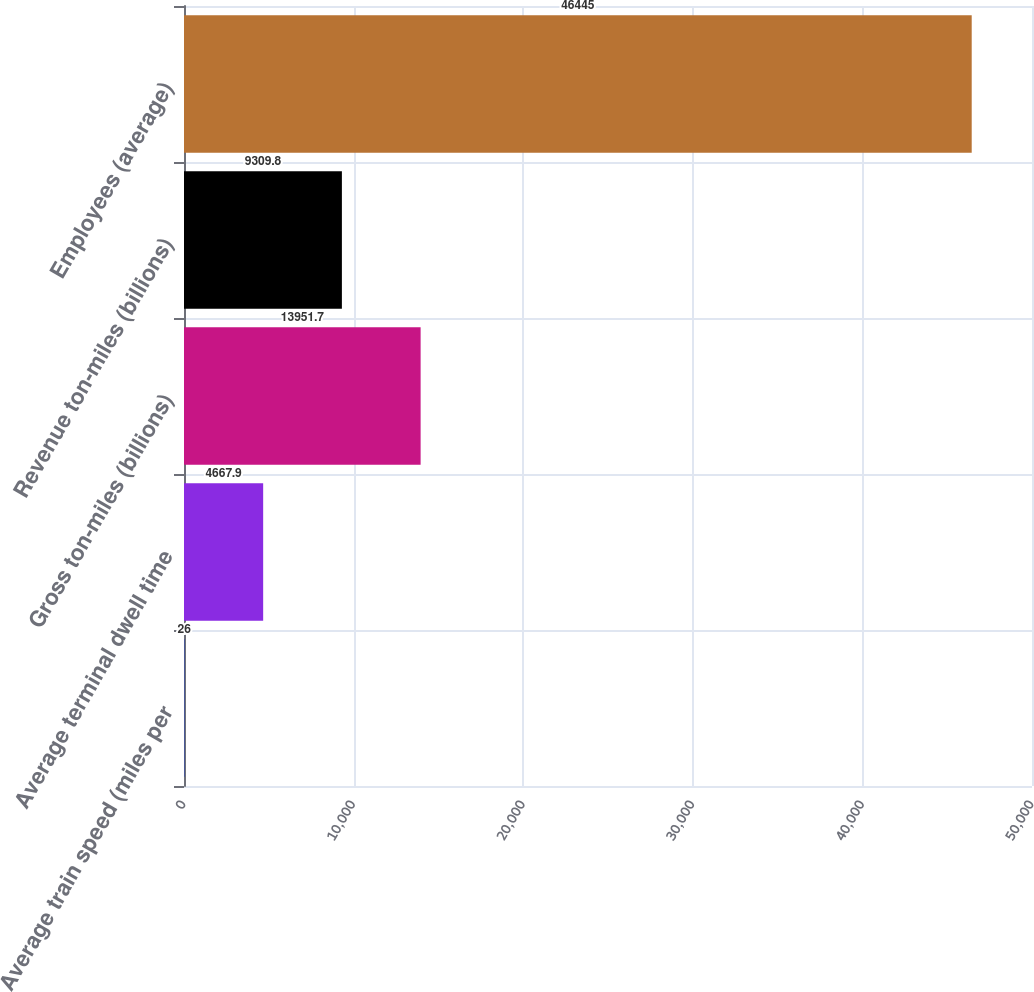Convert chart. <chart><loc_0><loc_0><loc_500><loc_500><bar_chart><fcel>Average train speed (miles per<fcel>Average terminal dwell time<fcel>Gross ton-miles (billions)<fcel>Revenue ton-miles (billions)<fcel>Employees (average)<nl><fcel>26<fcel>4667.9<fcel>13951.7<fcel>9309.8<fcel>46445<nl></chart> 